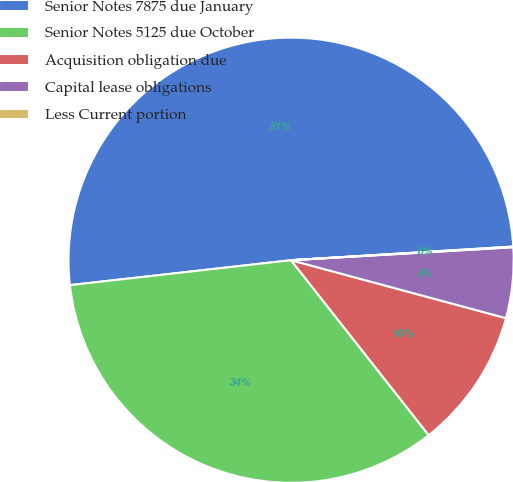Convert chart. <chart><loc_0><loc_0><loc_500><loc_500><pie_chart><fcel>Senior Notes 7875 due January<fcel>Senior Notes 5125 due October<fcel>Acquisition obligation due<fcel>Capital lease obligations<fcel>Less Current portion<nl><fcel>50.81%<fcel>33.82%<fcel>10.2%<fcel>5.12%<fcel>0.05%<nl></chart> 